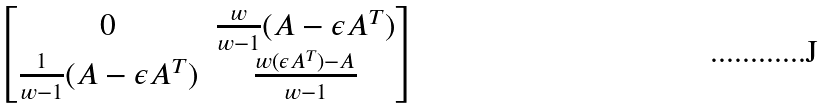Convert formula to latex. <formula><loc_0><loc_0><loc_500><loc_500>\begin{bmatrix} 0 & \frac { w } { w - 1 } ( A - \epsilon A ^ { T } ) \\ \frac { 1 } { w - 1 } ( A - \epsilon A ^ { T } ) & \frac { w ( \epsilon A ^ { T } ) - A } { w - 1 } \end{bmatrix}</formula> 